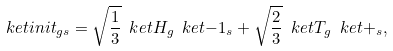Convert formula to latex. <formula><loc_0><loc_0><loc_500><loc_500>\ k e t { i n i t } _ { g s } = \sqrt { \frac { 1 } { 3 } } \ k e t { H } _ { g } \ k e t { - 1 } _ { s } + \sqrt { \frac { 2 } { 3 } } \ k e t { T } _ { g } \ k e t { + } _ { s } ,</formula> 